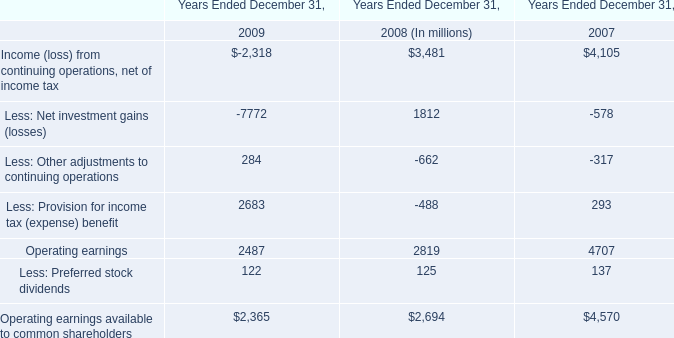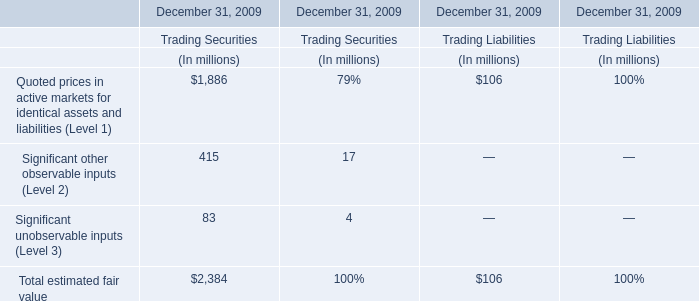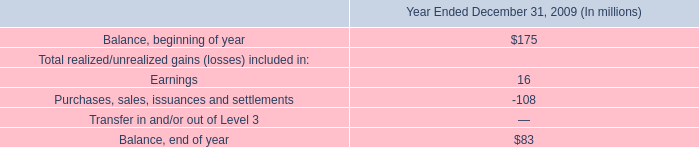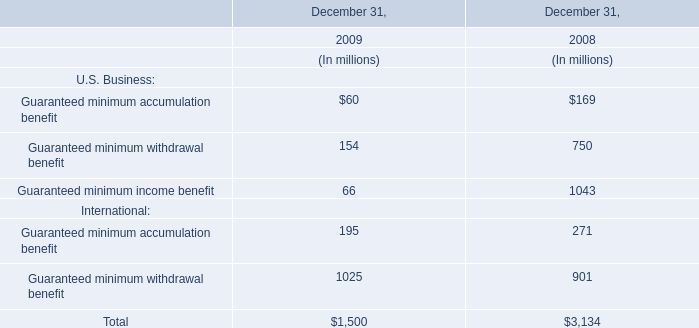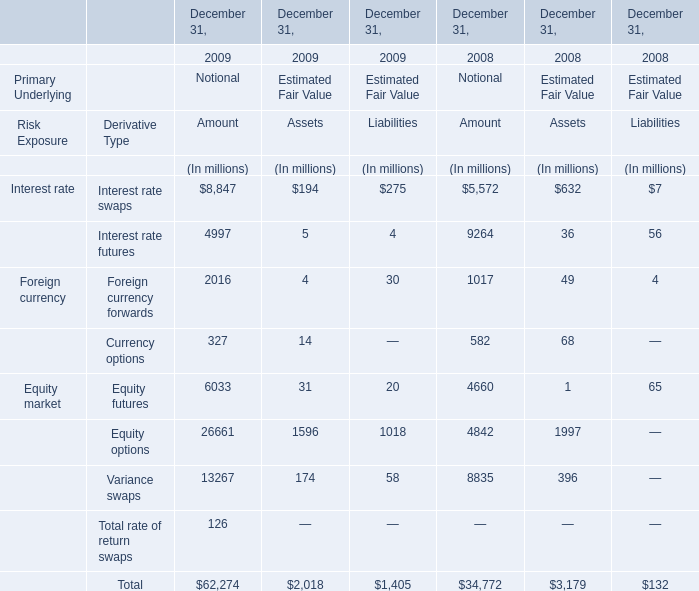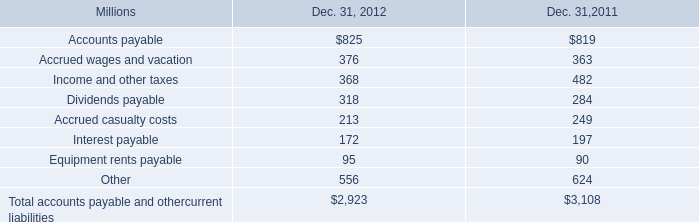What's the current growth rate of Guaranteed minimum withdrawal benefit in international? (in %) 
Computations: ((1025 - 901) / 901)
Answer: 0.13762. 